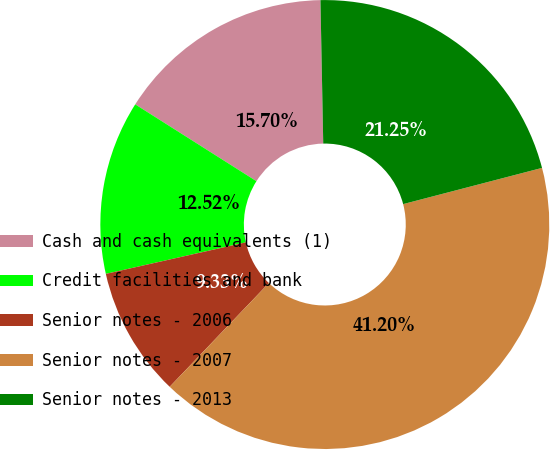Convert chart. <chart><loc_0><loc_0><loc_500><loc_500><pie_chart><fcel>Cash and cash equivalents (1)<fcel>Credit facilities and bank<fcel>Senior notes - 2006<fcel>Senior notes - 2007<fcel>Senior notes - 2013<nl><fcel>15.7%<fcel>12.52%<fcel>9.33%<fcel>41.2%<fcel>21.25%<nl></chart> 